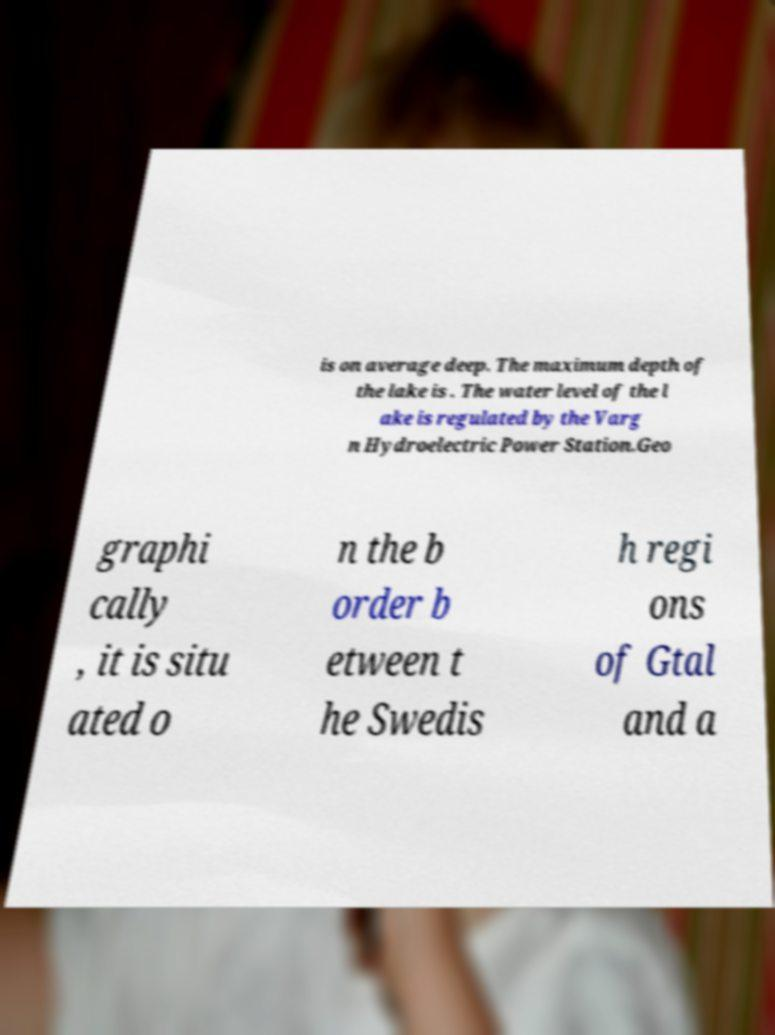What messages or text are displayed in this image? I need them in a readable, typed format. is on average deep. The maximum depth of the lake is . The water level of the l ake is regulated by the Varg n Hydroelectric Power Station.Geo graphi cally , it is situ ated o n the b order b etween t he Swedis h regi ons of Gtal and a 